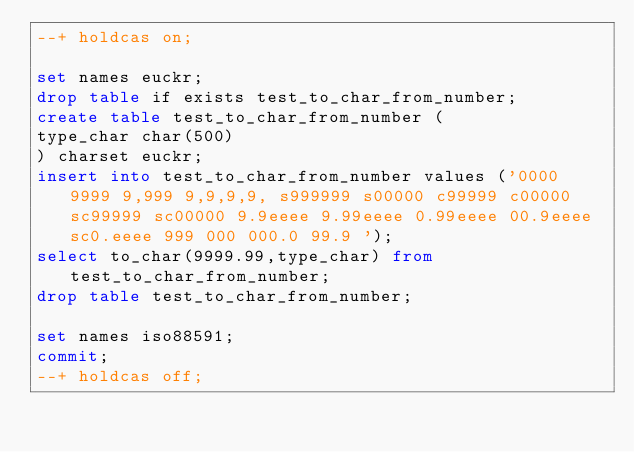Convert code to text. <code><loc_0><loc_0><loc_500><loc_500><_SQL_>--+ holdcas on;

set names euckr;
drop table if exists test_to_char_from_number;
create table test_to_char_from_number (
type_char char(500)
) charset euckr;
insert into test_to_char_from_number values ('0000 9999 9,999 9,9,9,9, s999999 s00000 c99999 c00000 sc99999 sc00000 9.9eeee 9.99eeee 0.99eeee 00.9eeee sc0.eeee 999 000 000.0 99.9 ');
select to_char(9999.99,type_char) from test_to_char_from_number;
drop table test_to_char_from_number;

set names iso88591;
commit;
--+ holdcas off;
</code> 